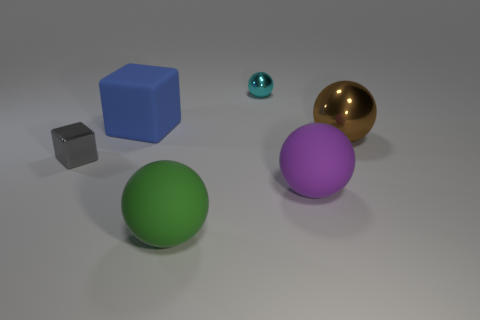The gray thing that is the same material as the small cyan object is what size?
Provide a succinct answer. Small. How many big objects are either gray rubber balls or blue blocks?
Offer a very short reply. 1. Is there a gray thing made of the same material as the small cyan thing?
Offer a terse response. Yes. What is the material of the small object that is on the left side of the big blue matte object?
Keep it short and to the point. Metal. What is the color of the thing that is the same size as the gray metallic block?
Make the answer very short. Cyan. How many other things are the same shape as the blue matte object?
Your answer should be very brief. 1. What is the size of the metallic object that is on the left side of the small cyan shiny ball?
Make the answer very short. Small. What number of shiny balls are right of the small object in front of the brown thing?
Keep it short and to the point. 2. What number of other things are the same size as the cyan object?
Offer a terse response. 1. Is the shape of the large matte object that is behind the tiny gray block the same as  the tiny gray metal object?
Offer a terse response. Yes. 